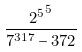Convert formula to latex. <formula><loc_0><loc_0><loc_500><loc_500>\frac { { 2 ^ { 5 } } ^ { 5 } } { 7 ^ { 3 1 7 } - 3 7 2 }</formula> 